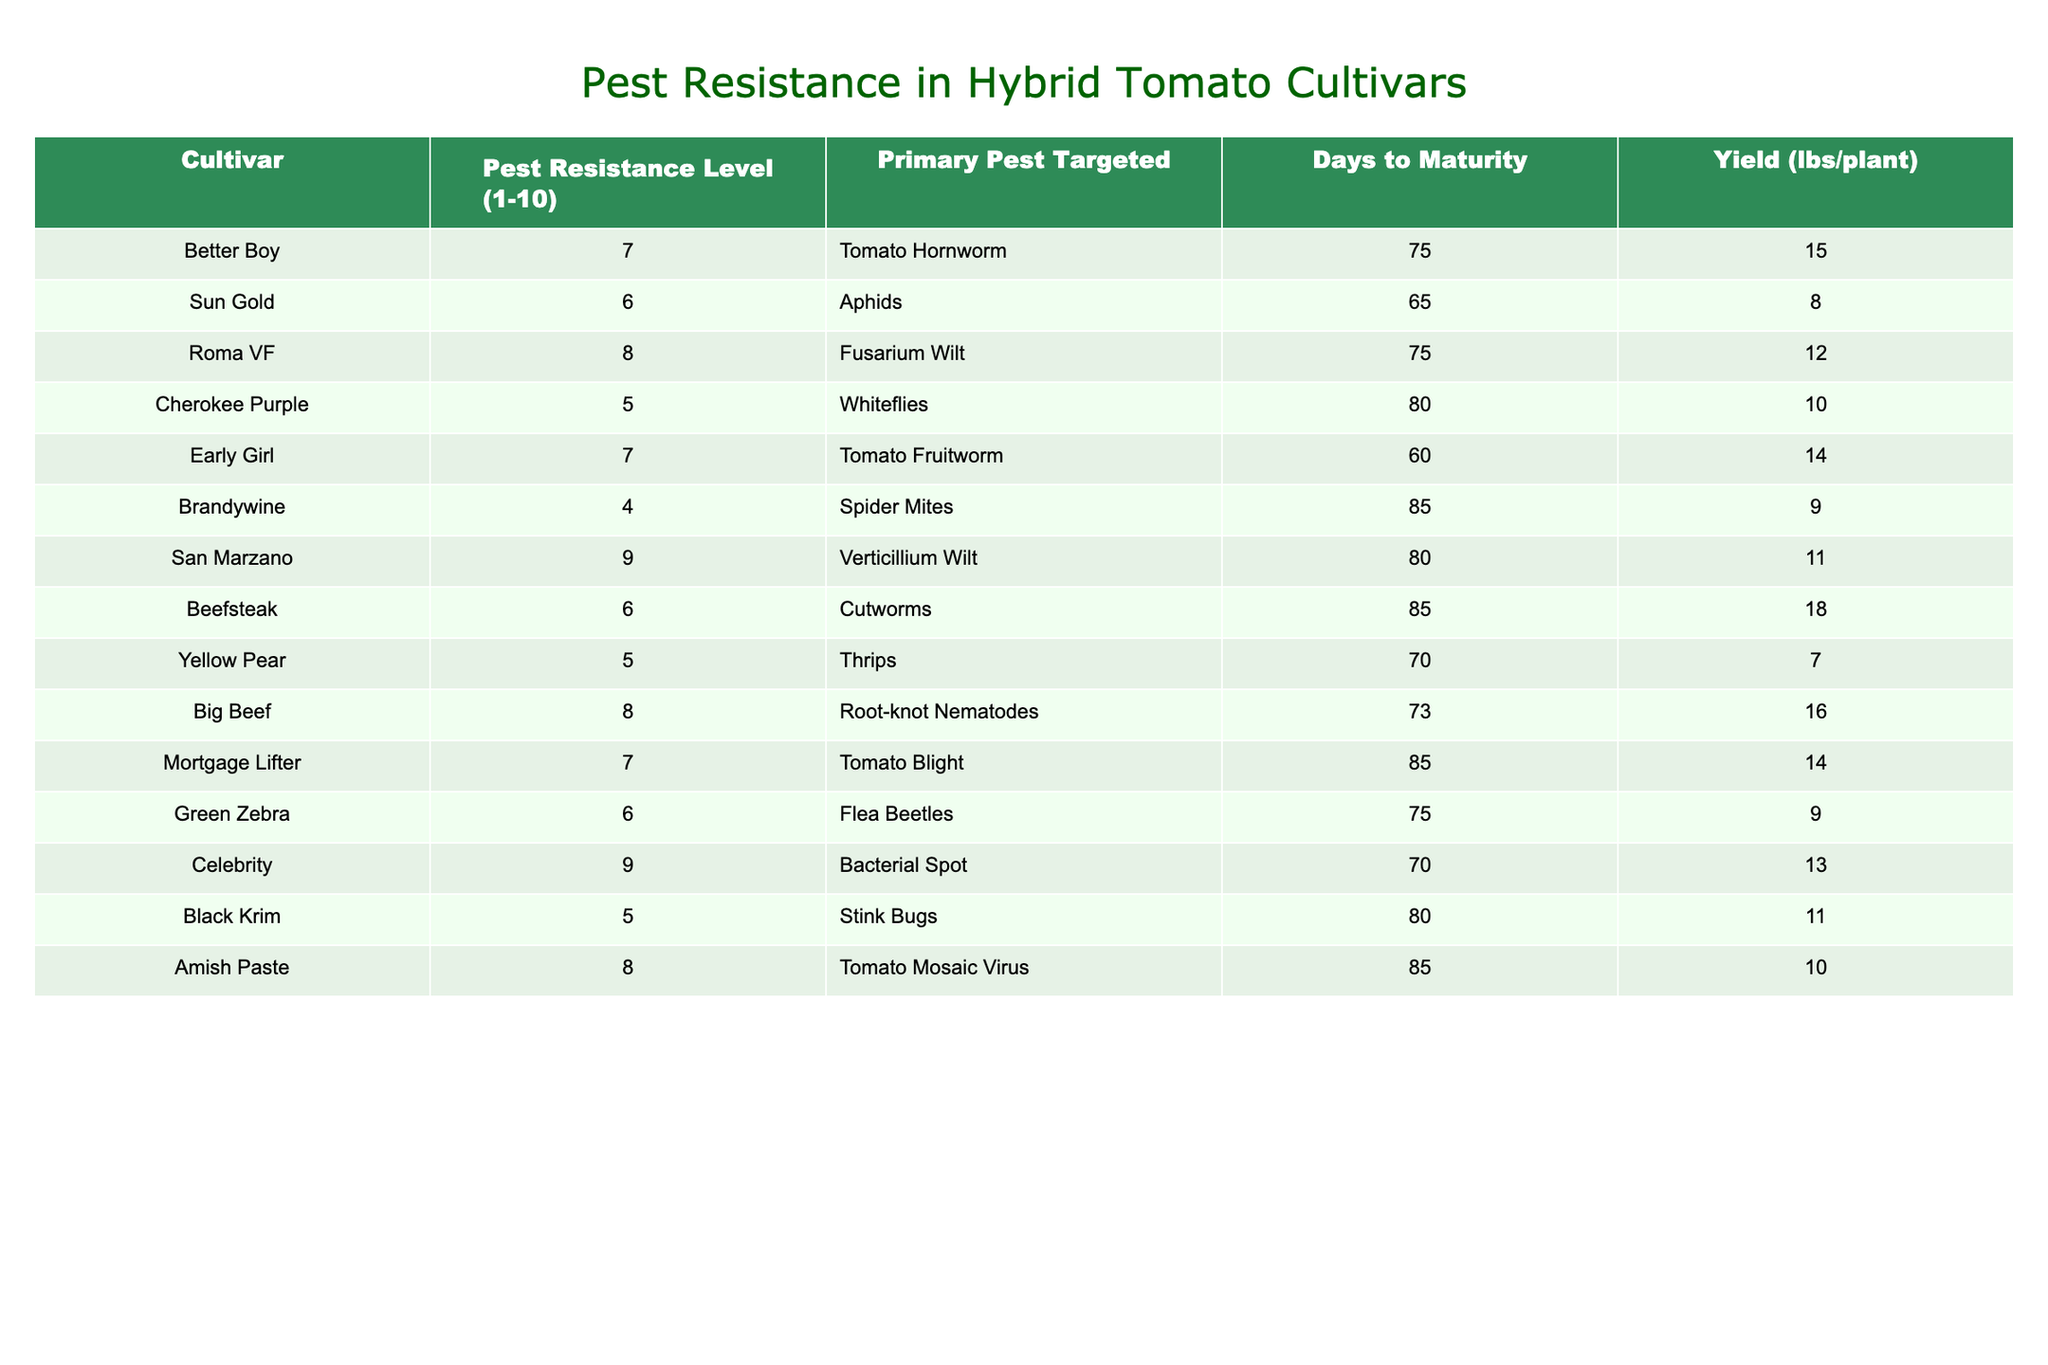What is the highest pest resistance level among the tomato cultivars? The highest pest resistance level in the table is found for 'San Marzano' with a resistance level of 9.
Answer: 9 Which cultivar has the lowest yield? The cultivar with the lowest yield is 'Yellow Pear' with a yield of 7 lbs per plant.
Answer: 7 lbs How many cultivars have a pest resistance level of 6? By reviewing the table, there are three cultivars with a pest resistance level of 6: 'Sun Gold', 'Beefsteak', and 'Green Zebra'.
Answer: 3 What is the average days to maturity for all cultivars? The total days to maturity for all 15 cultivars is 1157 days (75 + 65 + 75 + 80 + 60 + 85 + 80 + 85 + 70 + 73 + 85 + 70 + 80 + 85 + 85), and there are 15 cultivars. Dividing gives an average of 1157/15 = 77.13.
Answer: 77.13 Is 'Cherokee Purple' more resistant than 'Brandywine'? Comparing the pest resistance levels, 'Cherokee Purple' has a resistance level of 5, while 'Brandywine' has a resistance level of 4. Therefore, 'Cherokee Purple' is indeed more resistant.
Answer: Yes What is the total yield of cultivars with a pest resistance level of 8? The cultivars with a resistance level of 8 are 'Roma VF', 'Big Beef', and 'Amish Paste', with yields of 12, 16, and 10 lbs respectively. Adding them gives a total yield of 12 + 16 + 10 = 38 lbs.
Answer: 38 lbs What percentage of cultivars target the Tomato Hornworm? Only one cultivar, 'Better Boy', targets the Tomato Hornworm out of 15 total cultivars. Therefore, the percentage is (1/15) * 100 = 6.67%.
Answer: 6.67% Which pest has the most resistant cultivar and what is that level? The pest with the most resistant cultivar is 'Verticillium Wilt' as 'San Marzano' has a resistance level of 9, which is the highest.
Answer: 9 Are there any cultivars that mature in less than 70 days? Reviewing the days to maturity for each cultivar, only 'Early Girl' matures in 60 days, which is less than 70 days.
Answer: Yes What is the difference in yield between 'Beefsteak' and 'Roma VF'? 'Beefsteak' has a yield of 18 lbs while 'Roma VF' has a yield of 12 lbs. Thus, the difference is 18 - 12 = 6 lbs.
Answer: 6 lbs Which cultivar has the best resistance level against Fusarium Wilt? 'Roma VF' has the best resistance level against Fusarium Wilt with a resistance level of 8.
Answer: 8 